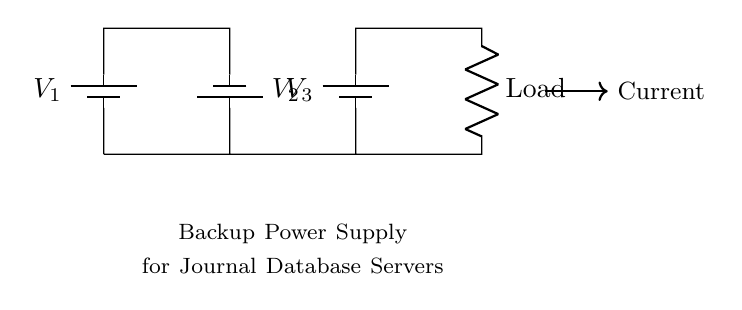What types of components are in this circuit? The circuit consists of batteries and a resistor, as indicated by the symbols in the diagram. There are three batteries and one load resistor.
Answer: batteries, resistor How many batteries are in series? The diagram clearly shows three batteries connected in series, each labeled as V1, V2, and V3. They are positioned one after the other along the same path.
Answer: three What is the purpose of the resistor? The resistor acts as a load in the circuit, which means it consumes power supplied by the batteries. It is labeled as "Load."
Answer: to consume power What is the total voltage of the circuit? In a series circuit, the total voltage is the sum of the individual battery voltages. Assuming each battery has a voltage of 1.5 volts, the total would be 4.5 volts.
Answer: 4.5 volts How does current flow in the circuit? The current flows from the positive terminal of the first battery through the load resistor and back to the negative terminal of the last battery, creating a continuous loop.
Answer: in a loop through the load What would happen if one battery fails? In a series circuit, if one battery fails (becomes an open circuit), the entire circuit would stop functioning because the current can no longer flow.
Answer: circuit stops functioning What is the significance of using a series configuration for backup power? Using a series configuration allows for a higher total voltage, which is useful for powering devices such as database servers that require more significant electrical energy to operate effectively.
Answer: higher voltage for power needs 